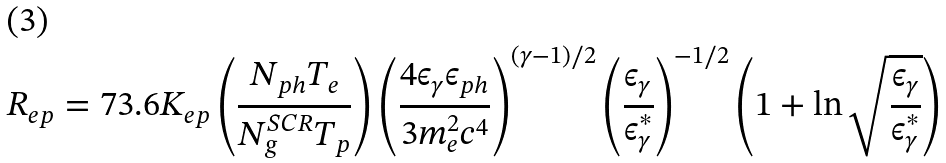<formula> <loc_0><loc_0><loc_500><loc_500>R _ { e p } = 7 3 . 6 K _ { e p } \left ( \frac { N _ { p h } T _ { e } } { N _ { g } ^ { S C R } T _ { p } } \right ) \left ( \frac { 4 \epsilon _ { \gamma } \epsilon _ { p h } } { 3 m _ { e } ^ { 2 } c ^ { 4 } } \right ) ^ { ( \gamma - 1 ) / 2 } \left ( \frac { \epsilon _ { \gamma } } { \epsilon _ { \gamma } ^ { * } } \right ) ^ { - 1 / 2 } \left ( 1 + \ln \sqrt { \frac { \epsilon _ { \gamma } } { \epsilon _ { \gamma } ^ { * } } } \right )</formula> 